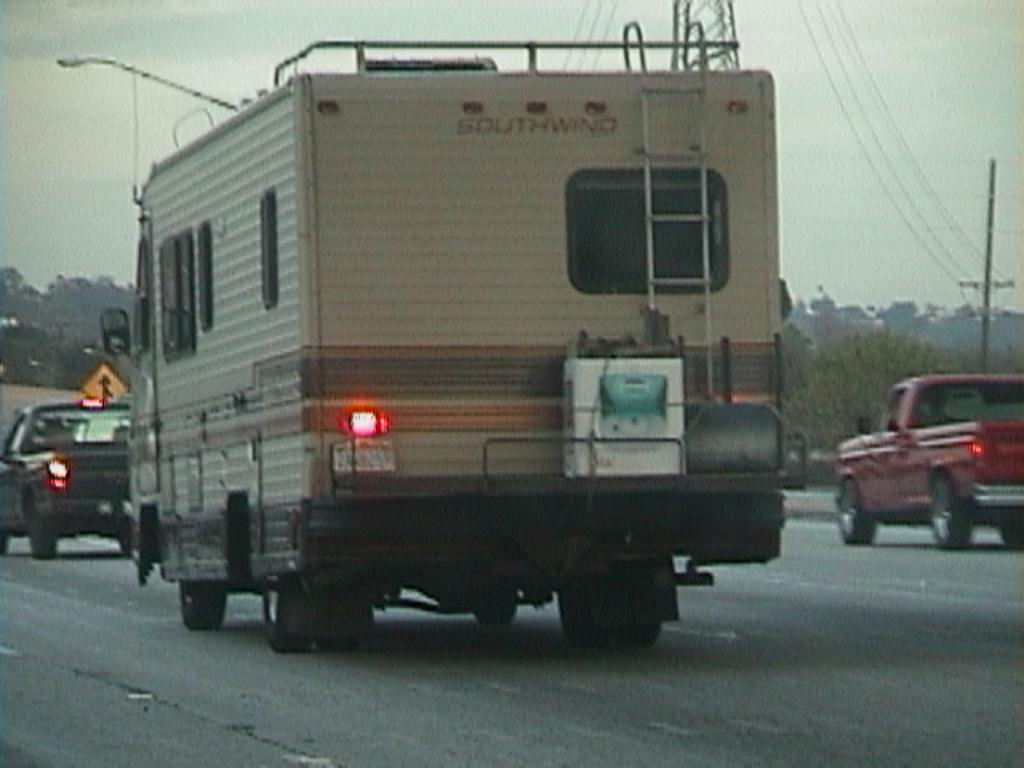What can be seen on the road in the image? There are vehicles on the road in the image. What is the lighting condition in the image? The lights are on in the image. What type of natural elements are visible in the image? There are trees visible in the image. What type of man-made structure is present in the image? There is a sign board in the image. What type of infrastructure is present in the image? There are electric poles and wires in the image. How many lizards are crawling on the electric poles in the image? There are no lizards present in the image; it only features vehicles, lights, trees, a sign board, electric poles, and wires. What type of liquid can be seen flowing through the wires in the image? There is no liquid flowing through the wires in the image; the wires are used for transmitting electricity. 